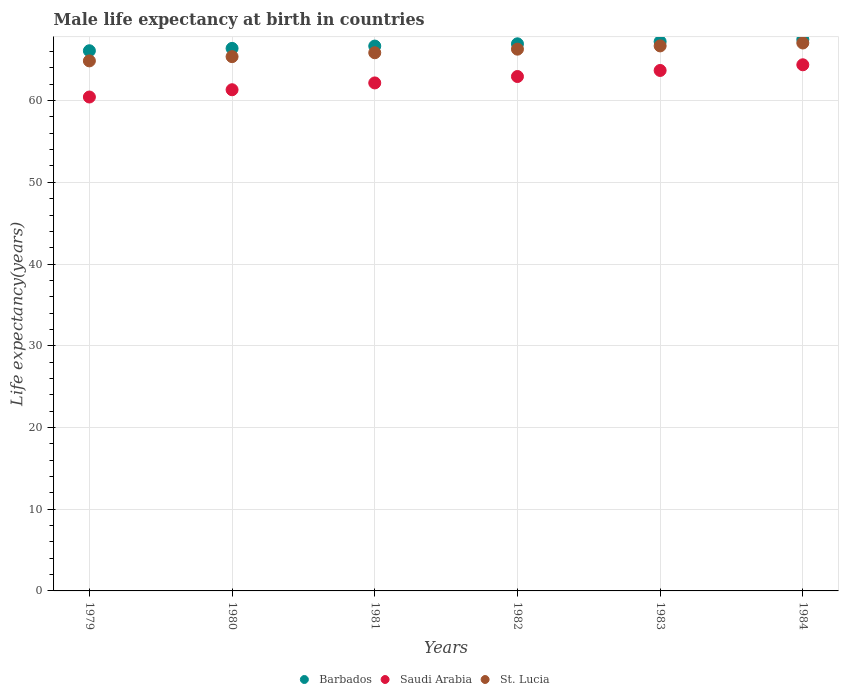What is the male life expectancy at birth in Saudi Arabia in 1981?
Your answer should be compact. 62.16. Across all years, what is the maximum male life expectancy at birth in Saudi Arabia?
Ensure brevity in your answer.  64.39. Across all years, what is the minimum male life expectancy at birth in St. Lucia?
Make the answer very short. 64.86. In which year was the male life expectancy at birth in Saudi Arabia maximum?
Offer a very short reply. 1984. In which year was the male life expectancy at birth in Saudi Arabia minimum?
Give a very brief answer. 1979. What is the total male life expectancy at birth in St. Lucia in the graph?
Provide a short and direct response. 396.15. What is the difference between the male life expectancy at birth in Barbados in 1979 and that in 1983?
Make the answer very short. -1.12. What is the difference between the male life expectancy at birth in St. Lucia in 1979 and the male life expectancy at birth in Saudi Arabia in 1982?
Offer a terse response. 1.91. What is the average male life expectancy at birth in Barbados per year?
Your response must be concise. 66.8. In the year 1984, what is the difference between the male life expectancy at birth in Saudi Arabia and male life expectancy at birth in Barbados?
Keep it short and to the point. -3.1. What is the ratio of the male life expectancy at birth in St. Lucia in 1979 to that in 1983?
Provide a succinct answer. 0.97. Is the male life expectancy at birth in Saudi Arabia in 1982 less than that in 1983?
Keep it short and to the point. Yes. What is the difference between the highest and the second highest male life expectancy at birth in Barbados?
Offer a terse response. 0.26. What is the difference between the highest and the lowest male life expectancy at birth in Barbados?
Offer a very short reply. 1.38. In how many years, is the male life expectancy at birth in Barbados greater than the average male life expectancy at birth in Barbados taken over all years?
Your response must be concise. 3. Is the sum of the male life expectancy at birth in St. Lucia in 1981 and 1984 greater than the maximum male life expectancy at birth in Saudi Arabia across all years?
Provide a short and direct response. Yes. Does the male life expectancy at birth in Saudi Arabia monotonically increase over the years?
Offer a very short reply. Yes. Is the male life expectancy at birth in Barbados strictly greater than the male life expectancy at birth in St. Lucia over the years?
Keep it short and to the point. Yes. How many dotlines are there?
Make the answer very short. 3. What is the difference between two consecutive major ticks on the Y-axis?
Offer a terse response. 10. Are the values on the major ticks of Y-axis written in scientific E-notation?
Provide a succinct answer. No. Does the graph contain grids?
Ensure brevity in your answer.  Yes. What is the title of the graph?
Ensure brevity in your answer.  Male life expectancy at birth in countries. Does "United States" appear as one of the legend labels in the graph?
Provide a succinct answer. No. What is the label or title of the Y-axis?
Offer a very short reply. Life expectancy(years). What is the Life expectancy(years) of Barbados in 1979?
Your response must be concise. 66.1. What is the Life expectancy(years) in Saudi Arabia in 1979?
Offer a very short reply. 60.44. What is the Life expectancy(years) of St. Lucia in 1979?
Provide a short and direct response. 64.86. What is the Life expectancy(years) of Barbados in 1980?
Your response must be concise. 66.39. What is the Life expectancy(years) of Saudi Arabia in 1980?
Provide a succinct answer. 61.33. What is the Life expectancy(years) of St. Lucia in 1980?
Keep it short and to the point. 65.38. What is the Life expectancy(years) in Barbados in 1981?
Provide a succinct answer. 66.67. What is the Life expectancy(years) of Saudi Arabia in 1981?
Your answer should be very brief. 62.16. What is the Life expectancy(years) of St. Lucia in 1981?
Give a very brief answer. 65.86. What is the Life expectancy(years) of Barbados in 1982?
Offer a terse response. 66.95. What is the Life expectancy(years) in Saudi Arabia in 1982?
Your answer should be compact. 62.95. What is the Life expectancy(years) in St. Lucia in 1982?
Give a very brief answer. 66.3. What is the Life expectancy(years) of Barbados in 1983?
Give a very brief answer. 67.22. What is the Life expectancy(years) of Saudi Arabia in 1983?
Ensure brevity in your answer.  63.69. What is the Life expectancy(years) of St. Lucia in 1983?
Your answer should be very brief. 66.69. What is the Life expectancy(years) of Barbados in 1984?
Offer a terse response. 67.48. What is the Life expectancy(years) in Saudi Arabia in 1984?
Your answer should be very brief. 64.39. What is the Life expectancy(years) of St. Lucia in 1984?
Your answer should be very brief. 67.05. Across all years, what is the maximum Life expectancy(years) of Barbados?
Offer a very short reply. 67.48. Across all years, what is the maximum Life expectancy(years) of Saudi Arabia?
Offer a very short reply. 64.39. Across all years, what is the maximum Life expectancy(years) in St. Lucia?
Give a very brief answer. 67.05. Across all years, what is the minimum Life expectancy(years) in Barbados?
Your answer should be very brief. 66.1. Across all years, what is the minimum Life expectancy(years) in Saudi Arabia?
Offer a terse response. 60.44. Across all years, what is the minimum Life expectancy(years) in St. Lucia?
Make the answer very short. 64.86. What is the total Life expectancy(years) in Barbados in the graph?
Keep it short and to the point. 400.83. What is the total Life expectancy(years) in Saudi Arabia in the graph?
Provide a succinct answer. 374.96. What is the total Life expectancy(years) of St. Lucia in the graph?
Provide a succinct answer. 396.15. What is the difference between the Life expectancy(years) in Barbados in 1979 and that in 1980?
Your answer should be very brief. -0.29. What is the difference between the Life expectancy(years) of Saudi Arabia in 1979 and that in 1980?
Offer a very short reply. -0.89. What is the difference between the Life expectancy(years) of St. Lucia in 1979 and that in 1980?
Provide a succinct answer. -0.52. What is the difference between the Life expectancy(years) in Barbados in 1979 and that in 1981?
Your answer should be compact. -0.57. What is the difference between the Life expectancy(years) in Saudi Arabia in 1979 and that in 1981?
Give a very brief answer. -1.72. What is the difference between the Life expectancy(years) of St. Lucia in 1979 and that in 1981?
Your answer should be compact. -1. What is the difference between the Life expectancy(years) in Barbados in 1979 and that in 1982?
Ensure brevity in your answer.  -0.85. What is the difference between the Life expectancy(years) in Saudi Arabia in 1979 and that in 1982?
Your answer should be compact. -2.51. What is the difference between the Life expectancy(years) of St. Lucia in 1979 and that in 1982?
Your response must be concise. -1.43. What is the difference between the Life expectancy(years) of Barbados in 1979 and that in 1983?
Ensure brevity in your answer.  -1.12. What is the difference between the Life expectancy(years) of Saudi Arabia in 1979 and that in 1983?
Keep it short and to the point. -3.25. What is the difference between the Life expectancy(years) of St. Lucia in 1979 and that in 1983?
Provide a succinct answer. -1.83. What is the difference between the Life expectancy(years) of Barbados in 1979 and that in 1984?
Offer a very short reply. -1.38. What is the difference between the Life expectancy(years) in Saudi Arabia in 1979 and that in 1984?
Offer a very short reply. -3.94. What is the difference between the Life expectancy(years) in St. Lucia in 1979 and that in 1984?
Ensure brevity in your answer.  -2.19. What is the difference between the Life expectancy(years) in Barbados in 1980 and that in 1981?
Offer a very short reply. -0.28. What is the difference between the Life expectancy(years) of Saudi Arabia in 1980 and that in 1981?
Your answer should be very brief. -0.83. What is the difference between the Life expectancy(years) of St. Lucia in 1980 and that in 1981?
Give a very brief answer. -0.48. What is the difference between the Life expectancy(years) in Barbados in 1980 and that in 1982?
Keep it short and to the point. -0.56. What is the difference between the Life expectancy(years) in Saudi Arabia in 1980 and that in 1982?
Provide a short and direct response. -1.62. What is the difference between the Life expectancy(years) in St. Lucia in 1980 and that in 1982?
Keep it short and to the point. -0.92. What is the difference between the Life expectancy(years) of Barbados in 1980 and that in 1983?
Your answer should be very brief. -0.83. What is the difference between the Life expectancy(years) in Saudi Arabia in 1980 and that in 1983?
Ensure brevity in your answer.  -2.36. What is the difference between the Life expectancy(years) of St. Lucia in 1980 and that in 1983?
Provide a succinct answer. -1.31. What is the difference between the Life expectancy(years) of Barbados in 1980 and that in 1984?
Offer a very short reply. -1.09. What is the difference between the Life expectancy(years) in Saudi Arabia in 1980 and that in 1984?
Offer a terse response. -3.05. What is the difference between the Life expectancy(years) in St. Lucia in 1980 and that in 1984?
Provide a short and direct response. -1.67. What is the difference between the Life expectancy(years) in Barbados in 1981 and that in 1982?
Provide a succinct answer. -0.28. What is the difference between the Life expectancy(years) in Saudi Arabia in 1981 and that in 1982?
Provide a succinct answer. -0.79. What is the difference between the Life expectancy(years) of St. Lucia in 1981 and that in 1982?
Your answer should be very brief. -0.44. What is the difference between the Life expectancy(years) of Barbados in 1981 and that in 1983?
Keep it short and to the point. -0.55. What is the difference between the Life expectancy(years) of Saudi Arabia in 1981 and that in 1983?
Make the answer very short. -1.52. What is the difference between the Life expectancy(years) in St. Lucia in 1981 and that in 1983?
Your answer should be very brief. -0.84. What is the difference between the Life expectancy(years) in Barbados in 1981 and that in 1984?
Make the answer very short. -0.81. What is the difference between the Life expectancy(years) in Saudi Arabia in 1981 and that in 1984?
Offer a terse response. -2.22. What is the difference between the Life expectancy(years) of St. Lucia in 1981 and that in 1984?
Give a very brief answer. -1.19. What is the difference between the Life expectancy(years) of Barbados in 1982 and that in 1983?
Your answer should be very brief. -0.27. What is the difference between the Life expectancy(years) of Saudi Arabia in 1982 and that in 1983?
Offer a very short reply. -0.74. What is the difference between the Life expectancy(years) in St. Lucia in 1982 and that in 1983?
Make the answer very short. -0.4. What is the difference between the Life expectancy(years) of Barbados in 1982 and that in 1984?
Provide a short and direct response. -0.53. What is the difference between the Life expectancy(years) in Saudi Arabia in 1982 and that in 1984?
Keep it short and to the point. -1.44. What is the difference between the Life expectancy(years) in St. Lucia in 1982 and that in 1984?
Make the answer very short. -0.76. What is the difference between the Life expectancy(years) in Barbados in 1983 and that in 1984?
Ensure brevity in your answer.  -0.26. What is the difference between the Life expectancy(years) in Saudi Arabia in 1983 and that in 1984?
Your answer should be compact. -0.69. What is the difference between the Life expectancy(years) in St. Lucia in 1983 and that in 1984?
Make the answer very short. -0.36. What is the difference between the Life expectancy(years) of Barbados in 1979 and the Life expectancy(years) of Saudi Arabia in 1980?
Your answer should be very brief. 4.77. What is the difference between the Life expectancy(years) in Barbados in 1979 and the Life expectancy(years) in St. Lucia in 1980?
Offer a terse response. 0.72. What is the difference between the Life expectancy(years) of Saudi Arabia in 1979 and the Life expectancy(years) of St. Lucia in 1980?
Offer a very short reply. -4.94. What is the difference between the Life expectancy(years) of Barbados in 1979 and the Life expectancy(years) of Saudi Arabia in 1981?
Give a very brief answer. 3.94. What is the difference between the Life expectancy(years) of Barbados in 1979 and the Life expectancy(years) of St. Lucia in 1981?
Provide a short and direct response. 0.24. What is the difference between the Life expectancy(years) in Saudi Arabia in 1979 and the Life expectancy(years) in St. Lucia in 1981?
Your answer should be very brief. -5.42. What is the difference between the Life expectancy(years) of Barbados in 1979 and the Life expectancy(years) of Saudi Arabia in 1982?
Provide a succinct answer. 3.15. What is the difference between the Life expectancy(years) of Barbados in 1979 and the Life expectancy(years) of St. Lucia in 1982?
Give a very brief answer. -0.19. What is the difference between the Life expectancy(years) of Saudi Arabia in 1979 and the Life expectancy(years) of St. Lucia in 1982?
Make the answer very short. -5.86. What is the difference between the Life expectancy(years) in Barbados in 1979 and the Life expectancy(years) in Saudi Arabia in 1983?
Keep it short and to the point. 2.41. What is the difference between the Life expectancy(years) in Barbados in 1979 and the Life expectancy(years) in St. Lucia in 1983?
Provide a succinct answer. -0.59. What is the difference between the Life expectancy(years) of Saudi Arabia in 1979 and the Life expectancy(years) of St. Lucia in 1983?
Ensure brevity in your answer.  -6.25. What is the difference between the Life expectancy(years) in Barbados in 1979 and the Life expectancy(years) in Saudi Arabia in 1984?
Your answer should be compact. 1.72. What is the difference between the Life expectancy(years) of Barbados in 1979 and the Life expectancy(years) of St. Lucia in 1984?
Provide a short and direct response. -0.95. What is the difference between the Life expectancy(years) in Saudi Arabia in 1979 and the Life expectancy(years) in St. Lucia in 1984?
Offer a very short reply. -6.61. What is the difference between the Life expectancy(years) of Barbados in 1980 and the Life expectancy(years) of Saudi Arabia in 1981?
Your answer should be compact. 4.23. What is the difference between the Life expectancy(years) of Barbados in 1980 and the Life expectancy(years) of St. Lucia in 1981?
Provide a short and direct response. 0.53. What is the difference between the Life expectancy(years) in Saudi Arabia in 1980 and the Life expectancy(years) in St. Lucia in 1981?
Provide a succinct answer. -4.53. What is the difference between the Life expectancy(years) of Barbados in 1980 and the Life expectancy(years) of Saudi Arabia in 1982?
Keep it short and to the point. 3.44. What is the difference between the Life expectancy(years) of Barbados in 1980 and the Life expectancy(years) of St. Lucia in 1982?
Keep it short and to the point. 0.1. What is the difference between the Life expectancy(years) of Saudi Arabia in 1980 and the Life expectancy(years) of St. Lucia in 1982?
Your response must be concise. -4.97. What is the difference between the Life expectancy(years) of Barbados in 1980 and the Life expectancy(years) of Saudi Arabia in 1983?
Provide a succinct answer. 2.7. What is the difference between the Life expectancy(years) of Barbados in 1980 and the Life expectancy(years) of St. Lucia in 1983?
Ensure brevity in your answer.  -0.3. What is the difference between the Life expectancy(years) in Saudi Arabia in 1980 and the Life expectancy(years) in St. Lucia in 1983?
Your answer should be very brief. -5.36. What is the difference between the Life expectancy(years) of Barbados in 1980 and the Life expectancy(years) of Saudi Arabia in 1984?
Your answer should be compact. 2.01. What is the difference between the Life expectancy(years) in Barbados in 1980 and the Life expectancy(years) in St. Lucia in 1984?
Your answer should be very brief. -0.66. What is the difference between the Life expectancy(years) of Saudi Arabia in 1980 and the Life expectancy(years) of St. Lucia in 1984?
Provide a succinct answer. -5.72. What is the difference between the Life expectancy(years) of Barbados in 1981 and the Life expectancy(years) of Saudi Arabia in 1982?
Offer a very short reply. 3.73. What is the difference between the Life expectancy(years) in Barbados in 1981 and the Life expectancy(years) in St. Lucia in 1982?
Provide a succinct answer. 0.38. What is the difference between the Life expectancy(years) of Saudi Arabia in 1981 and the Life expectancy(years) of St. Lucia in 1982?
Give a very brief answer. -4.13. What is the difference between the Life expectancy(years) of Barbados in 1981 and the Life expectancy(years) of Saudi Arabia in 1983?
Your response must be concise. 2.98. What is the difference between the Life expectancy(years) of Barbados in 1981 and the Life expectancy(years) of St. Lucia in 1983?
Provide a succinct answer. -0.02. What is the difference between the Life expectancy(years) of Saudi Arabia in 1981 and the Life expectancy(years) of St. Lucia in 1983?
Offer a very short reply. -4.53. What is the difference between the Life expectancy(years) in Barbados in 1981 and the Life expectancy(years) in Saudi Arabia in 1984?
Your response must be concise. 2.29. What is the difference between the Life expectancy(years) in Barbados in 1981 and the Life expectancy(years) in St. Lucia in 1984?
Provide a succinct answer. -0.38. What is the difference between the Life expectancy(years) in Saudi Arabia in 1981 and the Life expectancy(years) in St. Lucia in 1984?
Offer a terse response. -4.89. What is the difference between the Life expectancy(years) in Barbados in 1982 and the Life expectancy(years) in Saudi Arabia in 1983?
Your answer should be compact. 3.26. What is the difference between the Life expectancy(years) of Barbados in 1982 and the Life expectancy(years) of St. Lucia in 1983?
Your response must be concise. 0.26. What is the difference between the Life expectancy(years) in Saudi Arabia in 1982 and the Life expectancy(years) in St. Lucia in 1983?
Offer a very short reply. -3.75. What is the difference between the Life expectancy(years) of Barbados in 1982 and the Life expectancy(years) of Saudi Arabia in 1984?
Offer a terse response. 2.57. What is the difference between the Life expectancy(years) in Barbados in 1982 and the Life expectancy(years) in St. Lucia in 1984?
Provide a succinct answer. -0.1. What is the difference between the Life expectancy(years) in Saudi Arabia in 1982 and the Life expectancy(years) in St. Lucia in 1984?
Your answer should be very brief. -4.1. What is the difference between the Life expectancy(years) in Barbados in 1983 and the Life expectancy(years) in Saudi Arabia in 1984?
Keep it short and to the point. 2.84. What is the difference between the Life expectancy(years) in Barbados in 1983 and the Life expectancy(years) in St. Lucia in 1984?
Give a very brief answer. 0.17. What is the difference between the Life expectancy(years) in Saudi Arabia in 1983 and the Life expectancy(years) in St. Lucia in 1984?
Make the answer very short. -3.36. What is the average Life expectancy(years) in Barbados per year?
Provide a succinct answer. 66.8. What is the average Life expectancy(years) of Saudi Arabia per year?
Offer a very short reply. 62.49. What is the average Life expectancy(years) of St. Lucia per year?
Offer a terse response. 66.02. In the year 1979, what is the difference between the Life expectancy(years) of Barbados and Life expectancy(years) of Saudi Arabia?
Make the answer very short. 5.66. In the year 1979, what is the difference between the Life expectancy(years) in Barbados and Life expectancy(years) in St. Lucia?
Your answer should be compact. 1.24. In the year 1979, what is the difference between the Life expectancy(years) in Saudi Arabia and Life expectancy(years) in St. Lucia?
Your answer should be compact. -4.42. In the year 1980, what is the difference between the Life expectancy(years) of Barbados and Life expectancy(years) of Saudi Arabia?
Make the answer very short. 5.06. In the year 1980, what is the difference between the Life expectancy(years) in Barbados and Life expectancy(years) in St. Lucia?
Provide a short and direct response. 1.01. In the year 1980, what is the difference between the Life expectancy(years) in Saudi Arabia and Life expectancy(years) in St. Lucia?
Your answer should be compact. -4.05. In the year 1981, what is the difference between the Life expectancy(years) in Barbados and Life expectancy(years) in Saudi Arabia?
Provide a succinct answer. 4.51. In the year 1981, what is the difference between the Life expectancy(years) of Barbados and Life expectancy(years) of St. Lucia?
Your answer should be compact. 0.82. In the year 1981, what is the difference between the Life expectancy(years) of Saudi Arabia and Life expectancy(years) of St. Lucia?
Keep it short and to the point. -3.69. In the year 1982, what is the difference between the Life expectancy(years) of Barbados and Life expectancy(years) of Saudi Arabia?
Make the answer very short. 4. In the year 1982, what is the difference between the Life expectancy(years) of Barbados and Life expectancy(years) of St. Lucia?
Keep it short and to the point. 0.65. In the year 1982, what is the difference between the Life expectancy(years) of Saudi Arabia and Life expectancy(years) of St. Lucia?
Offer a very short reply. -3.35. In the year 1983, what is the difference between the Life expectancy(years) in Barbados and Life expectancy(years) in Saudi Arabia?
Provide a short and direct response. 3.53. In the year 1983, what is the difference between the Life expectancy(years) of Barbados and Life expectancy(years) of St. Lucia?
Your response must be concise. 0.53. In the year 1983, what is the difference between the Life expectancy(years) in Saudi Arabia and Life expectancy(years) in St. Lucia?
Offer a terse response. -3. In the year 1984, what is the difference between the Life expectancy(years) in Barbados and Life expectancy(years) in Saudi Arabia?
Give a very brief answer. 3.1. In the year 1984, what is the difference between the Life expectancy(years) of Barbados and Life expectancy(years) of St. Lucia?
Provide a short and direct response. 0.43. In the year 1984, what is the difference between the Life expectancy(years) in Saudi Arabia and Life expectancy(years) in St. Lucia?
Provide a short and direct response. -2.67. What is the ratio of the Life expectancy(years) of Barbados in 1979 to that in 1980?
Give a very brief answer. 1. What is the ratio of the Life expectancy(years) of Saudi Arabia in 1979 to that in 1980?
Offer a terse response. 0.99. What is the ratio of the Life expectancy(years) of Saudi Arabia in 1979 to that in 1981?
Keep it short and to the point. 0.97. What is the ratio of the Life expectancy(years) in St. Lucia in 1979 to that in 1981?
Your answer should be very brief. 0.98. What is the ratio of the Life expectancy(years) in Barbados in 1979 to that in 1982?
Provide a succinct answer. 0.99. What is the ratio of the Life expectancy(years) of Saudi Arabia in 1979 to that in 1982?
Your answer should be very brief. 0.96. What is the ratio of the Life expectancy(years) of St. Lucia in 1979 to that in 1982?
Your response must be concise. 0.98. What is the ratio of the Life expectancy(years) of Barbados in 1979 to that in 1983?
Your response must be concise. 0.98. What is the ratio of the Life expectancy(years) in Saudi Arabia in 1979 to that in 1983?
Ensure brevity in your answer.  0.95. What is the ratio of the Life expectancy(years) of St. Lucia in 1979 to that in 1983?
Your response must be concise. 0.97. What is the ratio of the Life expectancy(years) of Barbados in 1979 to that in 1984?
Keep it short and to the point. 0.98. What is the ratio of the Life expectancy(years) in Saudi Arabia in 1979 to that in 1984?
Your response must be concise. 0.94. What is the ratio of the Life expectancy(years) of St. Lucia in 1979 to that in 1984?
Offer a terse response. 0.97. What is the ratio of the Life expectancy(years) of Saudi Arabia in 1980 to that in 1981?
Make the answer very short. 0.99. What is the ratio of the Life expectancy(years) of St. Lucia in 1980 to that in 1981?
Ensure brevity in your answer.  0.99. What is the ratio of the Life expectancy(years) of Saudi Arabia in 1980 to that in 1982?
Provide a succinct answer. 0.97. What is the ratio of the Life expectancy(years) of St. Lucia in 1980 to that in 1982?
Your answer should be compact. 0.99. What is the ratio of the Life expectancy(years) in Barbados in 1980 to that in 1983?
Offer a terse response. 0.99. What is the ratio of the Life expectancy(years) of St. Lucia in 1980 to that in 1983?
Give a very brief answer. 0.98. What is the ratio of the Life expectancy(years) in Barbados in 1980 to that in 1984?
Offer a very short reply. 0.98. What is the ratio of the Life expectancy(years) of Saudi Arabia in 1980 to that in 1984?
Your response must be concise. 0.95. What is the ratio of the Life expectancy(years) in St. Lucia in 1980 to that in 1984?
Your answer should be very brief. 0.98. What is the ratio of the Life expectancy(years) in Saudi Arabia in 1981 to that in 1982?
Provide a short and direct response. 0.99. What is the ratio of the Life expectancy(years) in St. Lucia in 1981 to that in 1982?
Your answer should be very brief. 0.99. What is the ratio of the Life expectancy(years) in Barbados in 1981 to that in 1983?
Your answer should be very brief. 0.99. What is the ratio of the Life expectancy(years) in Saudi Arabia in 1981 to that in 1983?
Offer a terse response. 0.98. What is the ratio of the Life expectancy(years) in St. Lucia in 1981 to that in 1983?
Give a very brief answer. 0.99. What is the ratio of the Life expectancy(years) of Barbados in 1981 to that in 1984?
Your response must be concise. 0.99. What is the ratio of the Life expectancy(years) of Saudi Arabia in 1981 to that in 1984?
Your response must be concise. 0.97. What is the ratio of the Life expectancy(years) of St. Lucia in 1981 to that in 1984?
Provide a succinct answer. 0.98. What is the ratio of the Life expectancy(years) of Barbados in 1982 to that in 1983?
Give a very brief answer. 1. What is the ratio of the Life expectancy(years) of Saudi Arabia in 1982 to that in 1983?
Give a very brief answer. 0.99. What is the ratio of the Life expectancy(years) of St. Lucia in 1982 to that in 1983?
Offer a very short reply. 0.99. What is the ratio of the Life expectancy(years) of Saudi Arabia in 1982 to that in 1984?
Offer a terse response. 0.98. What is the ratio of the Life expectancy(years) of St. Lucia in 1982 to that in 1984?
Give a very brief answer. 0.99. What is the ratio of the Life expectancy(years) of St. Lucia in 1983 to that in 1984?
Provide a succinct answer. 0.99. What is the difference between the highest and the second highest Life expectancy(years) in Barbados?
Give a very brief answer. 0.26. What is the difference between the highest and the second highest Life expectancy(years) of Saudi Arabia?
Offer a terse response. 0.69. What is the difference between the highest and the second highest Life expectancy(years) in St. Lucia?
Make the answer very short. 0.36. What is the difference between the highest and the lowest Life expectancy(years) of Barbados?
Make the answer very short. 1.38. What is the difference between the highest and the lowest Life expectancy(years) of Saudi Arabia?
Give a very brief answer. 3.94. What is the difference between the highest and the lowest Life expectancy(years) in St. Lucia?
Your answer should be very brief. 2.19. 